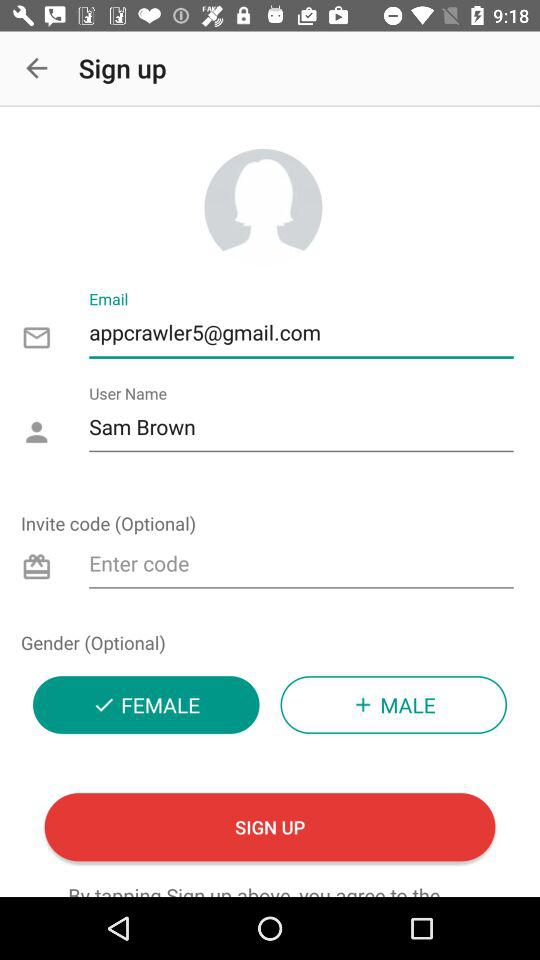How many fields are required to sign up?
Answer the question using a single word or phrase. 3 